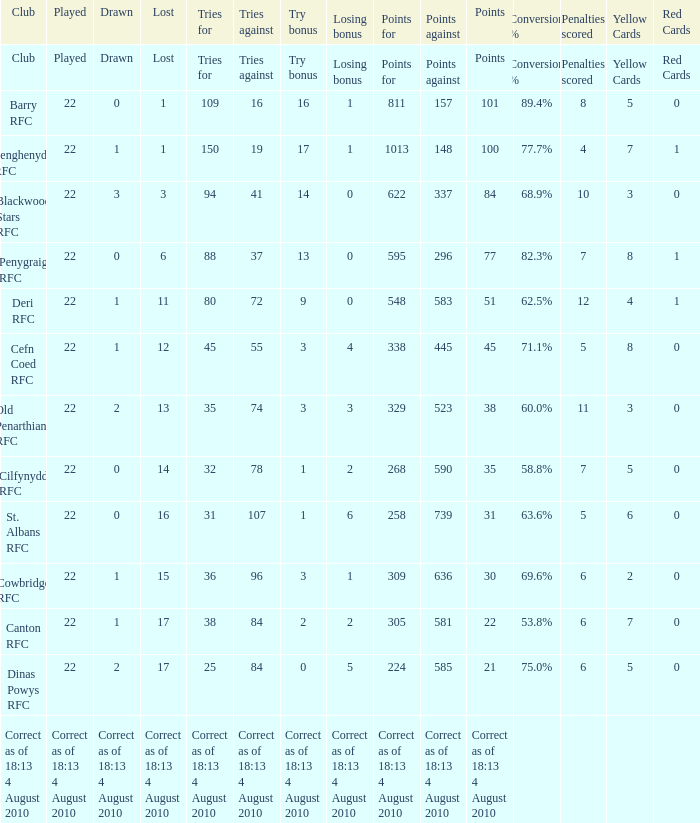What is the name of the club with 22 points? Canton RFC. 